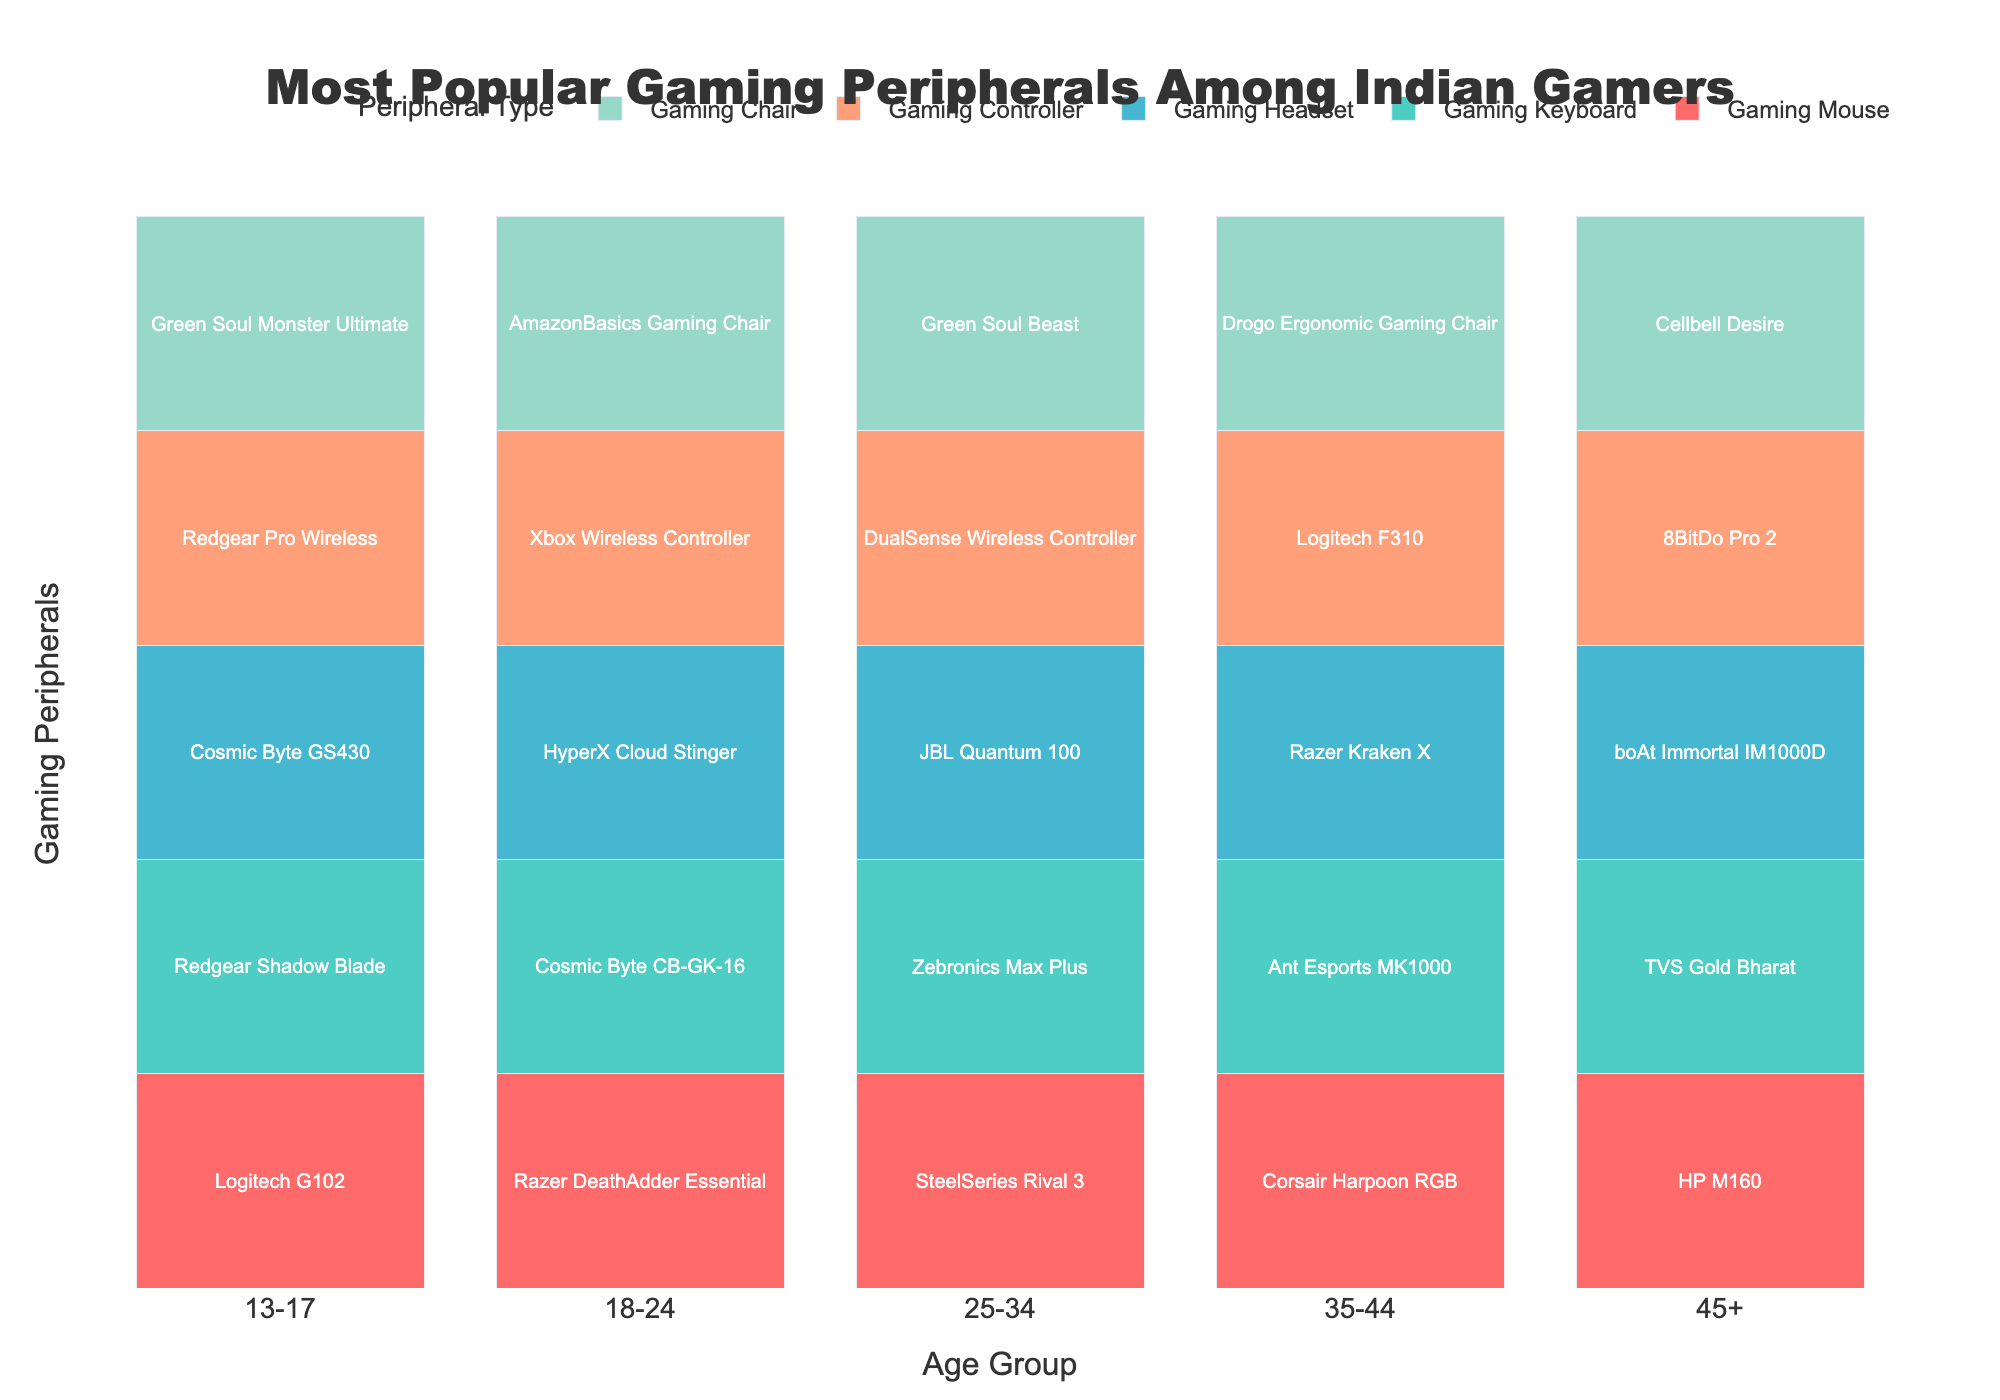Which age group uses the Razer Kraken X? The Razer Kraken X is listed under the "Gaming Headset" column for the age group "35-44".
Answer: 35-44 Which age group most commonly uses the largest range of peripheral brands? By examining the number of different brands listed for each age group, we notice that the "18-24" age group uses peripherals from multiple different brands, indicating a larger range.
Answer: 18-24 What is the preferred gaming controller for gamers aged 25-34? Looking under the "Gaming Controller" column for the age group "25-34", we find the preference listed as "DualSense Wireless Controller".
Answer: DualSense Wireless Controller Do more age groups use a Logitech product for gaming mice or for gaming controllers? By counting the occurrences, we see Logitech appears once for "Gaming Mice" (13-17: Logitech G102) and twice for "Gaming Controllers" (35-44: Logitech F310, 13-17: Redgear Pro Wireless by Logitech).
Answer: Gaming Controllers Which peripheral is shown in green color in the figure? Observing the color palette and matching to the visual, green is used for "Gaming Chair", such as the specific products listed under this type.
Answer: Gaming Chair How many age groups use a "Cosmic Byte" peripheral for either "Gaming Keyboard" or "Gaming Headset"? Looking at the age group data, "18-24" uses Cosmic Byte CB-GK-16 for "Gaming Keyboard" and "13-17" uses Cosmic Byte GS430 for "Gaming Headset".
Answer: 2 What is the common feature of the peripherals used by the 45+ age group? By examining the products listed under each peripheral category for the age group "45+", we notice they prefer budget-friendly and probably ergonomic products such as "Cellbell Desire".
Answer: Budget-friendly and ergonomic Which age group uses JBL gaming headsets? Checking the "Gaming Headset" column for all age groups, we find that the age group "25-34" uses the "JBL Quantum 100".
Answer: 25-34 Is there any peripheral that is only used by one specific age group? Yes, the "boAt Immortal IM1000D" headset is only listed under the "45+" age group in the "Gaming Headset" column.
Answer: Yes Which peripheral type has the most repetitive brand within different age groups? Examining all peripheral types and the brands used by each age group, we see that for "Gaming Chair," the brand "Green Soul" is used by both the "13-17" and "25-34" age groups, which is more repetitive compared to others.
Answer: Gaming Chair 